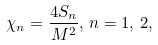<formula> <loc_0><loc_0><loc_500><loc_500>\chi _ { n } = \frac { 4 S _ { n } } { M ^ { 2 } } , \, n = 1 , \, 2 ,</formula> 